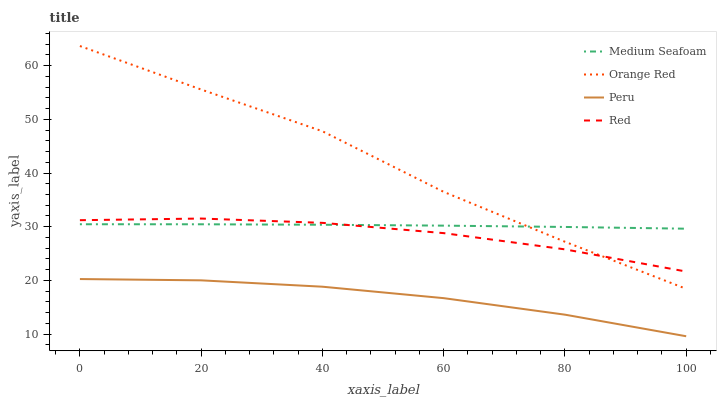Does Medium Seafoam have the minimum area under the curve?
Answer yes or no. No. Does Medium Seafoam have the maximum area under the curve?
Answer yes or no. No. Is Peru the smoothest?
Answer yes or no. No. Is Peru the roughest?
Answer yes or no. No. Does Medium Seafoam have the lowest value?
Answer yes or no. No. Does Medium Seafoam have the highest value?
Answer yes or no. No. Is Peru less than Red?
Answer yes or no. Yes. Is Orange Red greater than Peru?
Answer yes or no. Yes. Does Peru intersect Red?
Answer yes or no. No. 